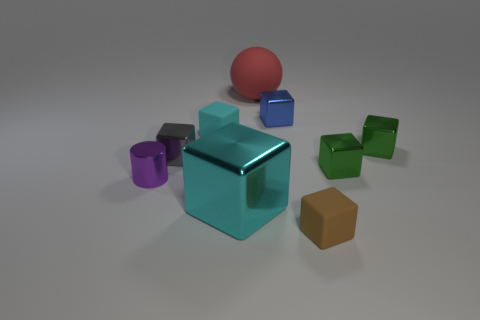Subtract 1 cubes. How many cubes are left? 6 Add 1 red matte cubes. How many objects exist? 10 Subtract all green blocks. How many blocks are left? 5 Subtract all gray metallic blocks. How many blocks are left? 6 Subtract all purple blocks. Subtract all purple cylinders. How many blocks are left? 7 Subtract all spheres. How many objects are left? 8 Subtract all blue things. Subtract all tiny metal objects. How many objects are left? 3 Add 3 metal blocks. How many metal blocks are left? 8 Add 4 tiny green rubber cylinders. How many tiny green rubber cylinders exist? 4 Subtract 0 red blocks. How many objects are left? 9 